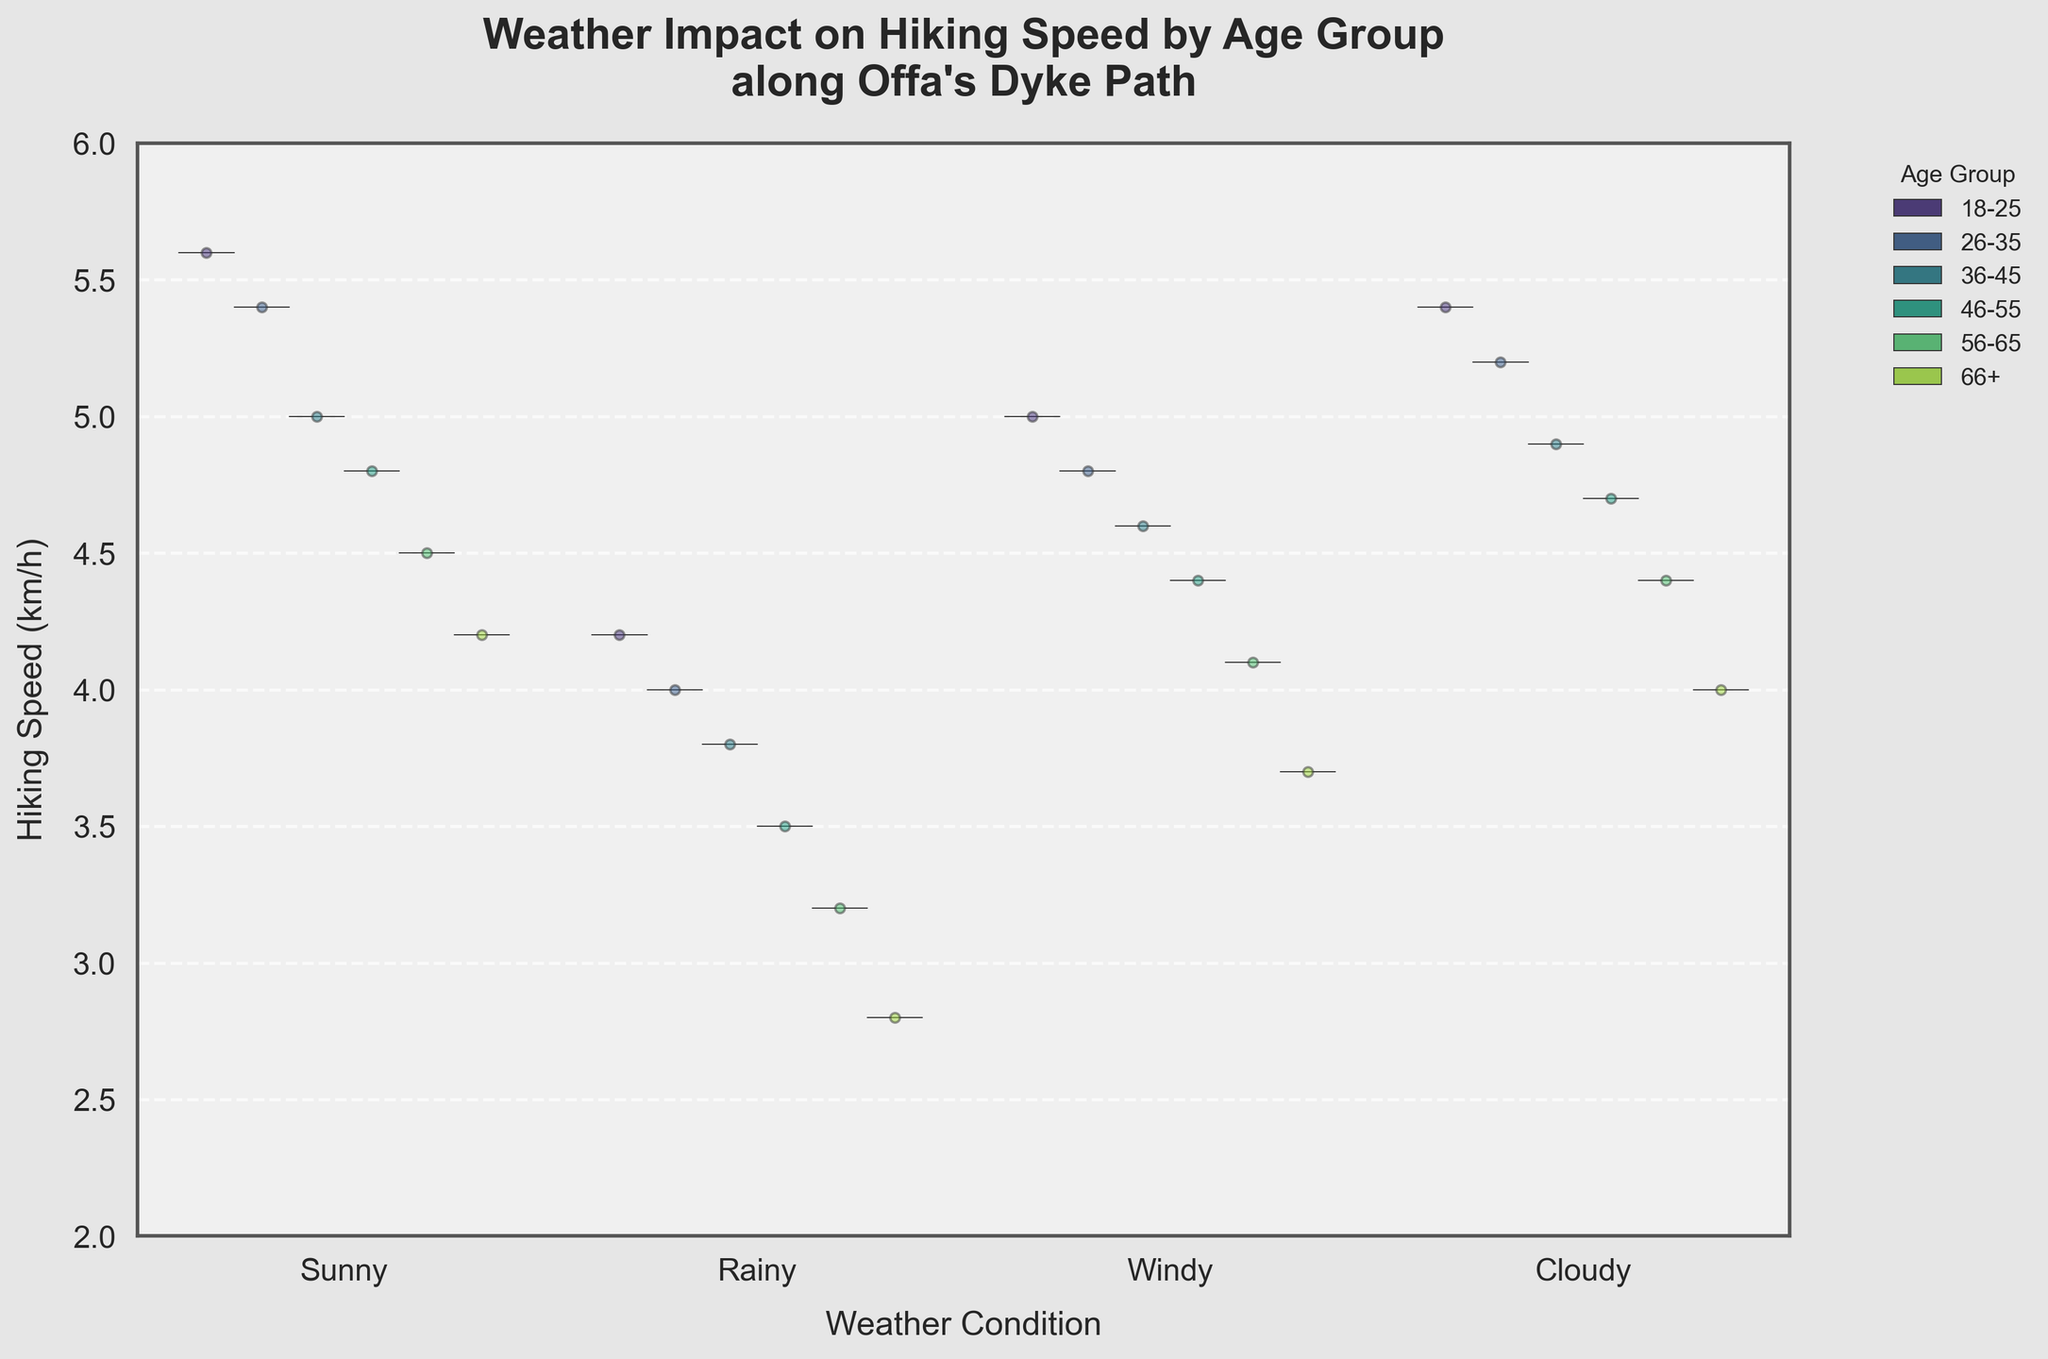How does the median hiking speed change with different weather conditions for the 18-25 age group? By examining the violin plot for the 18-25 age group under each weather condition, we can observe the median line within each violin. The order and position of the median lines across different conditions indicate the median hiking speeds.
Answer: The median speed is highest in Sunny and Cloudy conditions, slightly lower in Windy conditions, and lowest in Rainy conditions Which age group shows the greatest decrease in hiking speed from Sunny to Rainy conditions? Comparing the median lines of Sunny and Rainy conditions across each age group, we identify the one with the largest drop.
Answer: 66+ age group What is the average hiking speed for all age groups in Cloudy weather? By locating the positions of the data points within the jitter plots for Cloudy conditions and averaging them, we get an estimate of the average speed.
Answer: Approximately 4.7 km/h Which weather condition demonstrates the largest variability in hiking speeds for the 36-45 age group? By observing the spread of the data points and the width of the violins for the 36-45 age group across all weather conditions, the one with the broadest spread shows the largest variability.
Answer: Rainy Does the plot indicate any age group which maintains a relatively constant hiking speed across all weather conditions? By comparing the median lines and spread of the violins for each age group, an age group with similar median lines and narrower violins across all conditions shows consistency.
Answer: 18-25 age group Which age group has the highest median hiking speed in Sunny weather? By examining the median line within the Sunny condition violin plots for each age group and identifying the highest median line.
Answer: 18-25 age group Is there any correlation between the age group and the impact of Windy weather on hiking speed? By observing how the median and spread of hiking speeds in Windy conditions change across different age groups, we can infer any correlations. Generally, older age groups show a decrease in speed in Windy conditions compared to younger groups.
Answer: Generally, older age groups show a decrease For the 46-55 age group, how does the hiking speed in Cloudy weather compare to Sunny weather? Comparing the median lines and spread of the violins for the 46-55 age group under Cloudy and Sunny conditions.
Answer: Slightly lower in Cloudy than in Sunny 